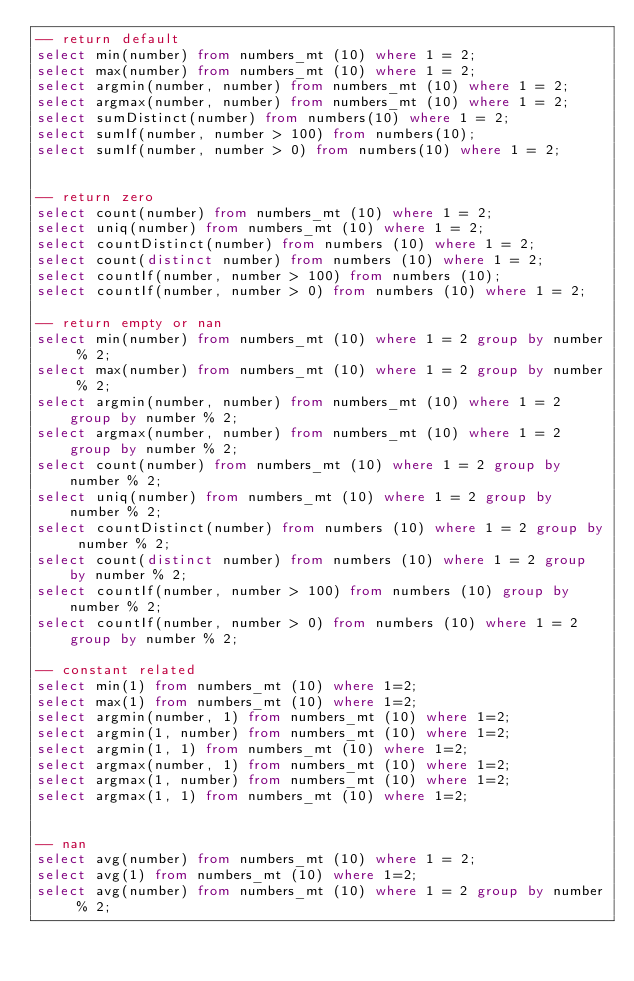Convert code to text. <code><loc_0><loc_0><loc_500><loc_500><_SQL_>-- return default
select min(number) from numbers_mt (10) where 1 = 2;
select max(number) from numbers_mt (10) where 1 = 2;
select argmin(number, number) from numbers_mt (10) where 1 = 2;
select argmax(number, number) from numbers_mt (10) where 1 = 2;
select sumDistinct(number) from numbers(10) where 1 = 2;
select sumIf(number, number > 100) from numbers(10);
select sumIf(number, number > 0) from numbers(10) where 1 = 2;


-- return zero
select count(number) from numbers_mt (10) where 1 = 2;
select uniq(number) from numbers_mt (10) where 1 = 2;
select countDistinct(number) from numbers (10) where 1 = 2;
select count(distinct number) from numbers (10) where 1 = 2;
select countIf(number, number > 100) from numbers (10);
select countIf(number, number > 0) from numbers (10) where 1 = 2;

-- return empty or nan
select min(number) from numbers_mt (10) where 1 = 2 group by number % 2;
select max(number) from numbers_mt (10) where 1 = 2 group by number % 2;
select argmin(number, number) from numbers_mt (10) where 1 = 2 group by number % 2;
select argmax(number, number) from numbers_mt (10) where 1 = 2 group by number % 2;
select count(number) from numbers_mt (10) where 1 = 2 group by number % 2;
select uniq(number) from numbers_mt (10) where 1 = 2 group by number % 2;
select countDistinct(number) from numbers (10) where 1 = 2 group by number % 2;
select count(distinct number) from numbers (10) where 1 = 2 group by number % 2;
select countIf(number, number > 100) from numbers (10) group by number % 2;
select countIf(number, number > 0) from numbers (10) where 1 = 2 group by number % 2;

-- constant related
select min(1) from numbers_mt (10) where 1=2;
select max(1) from numbers_mt (10) where 1=2;
select argmin(number, 1) from numbers_mt (10) where 1=2;
select argmin(1, number) from numbers_mt (10) where 1=2;
select argmin(1, 1) from numbers_mt (10) where 1=2;
select argmax(number, 1) from numbers_mt (10) where 1=2;
select argmax(1, number) from numbers_mt (10) where 1=2;
select argmax(1, 1) from numbers_mt (10) where 1=2;


-- nan
select avg(number) from numbers_mt (10) where 1 = 2;
select avg(1) from numbers_mt (10) where 1=2;
select avg(number) from numbers_mt (10) where 1 = 2 group by number % 2;

</code> 